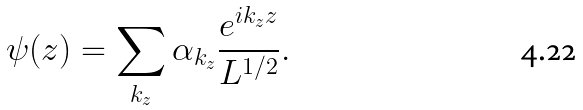Convert formula to latex. <formula><loc_0><loc_0><loc_500><loc_500>\psi ( z ) = \sum _ { k _ { z } } \alpha _ { k _ { z } } \frac { e ^ { i k _ { z } z } } { L ^ { 1 / 2 } } .</formula> 